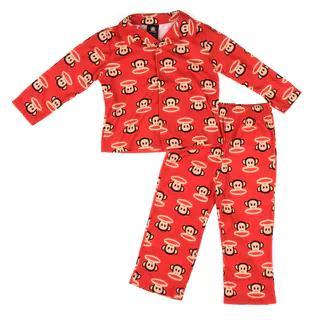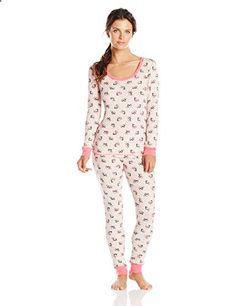The first image is the image on the left, the second image is the image on the right. For the images displayed, is the sentence "There is 1 or more woman modeling pajama's." factually correct? Answer yes or no. Yes. 